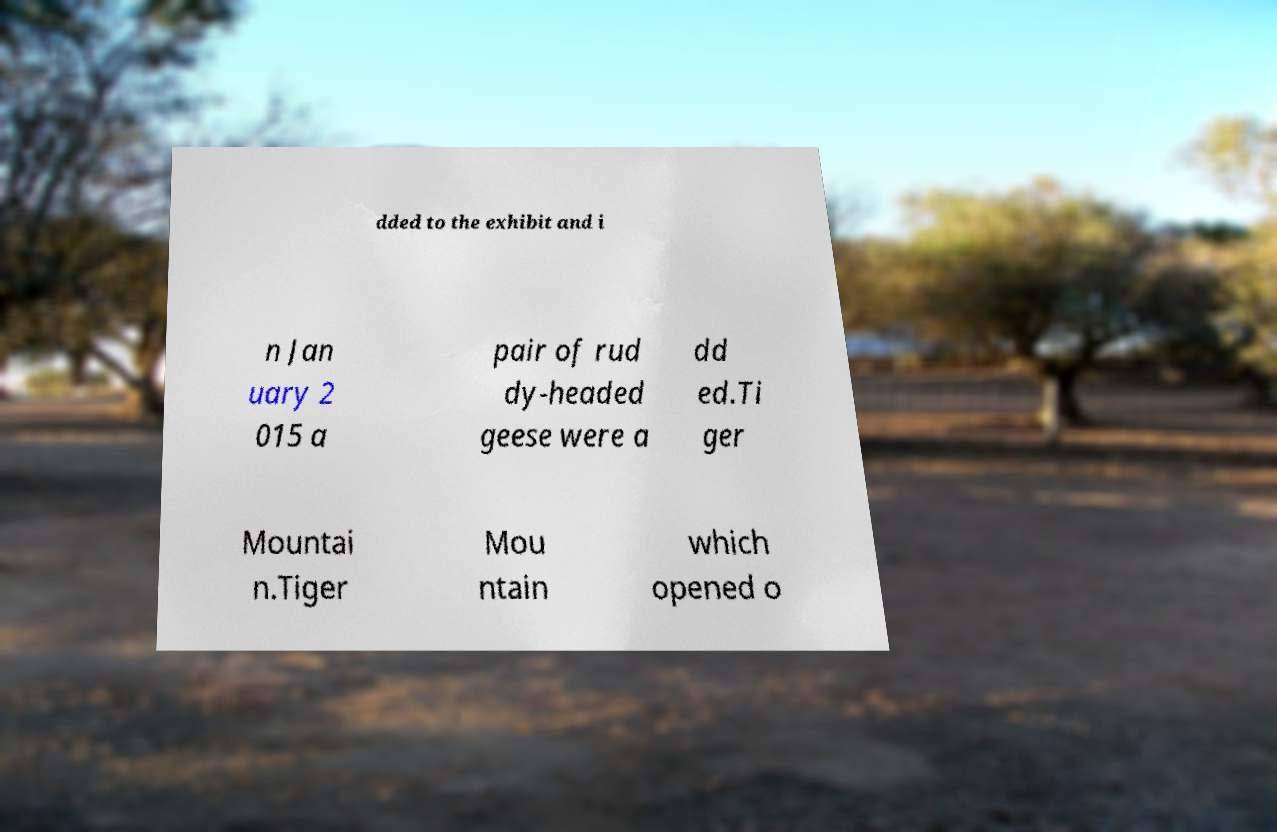Can you read and provide the text displayed in the image?This photo seems to have some interesting text. Can you extract and type it out for me? dded to the exhibit and i n Jan uary 2 015 a pair of rud dy-headed geese were a dd ed.Ti ger Mountai n.Tiger Mou ntain which opened o 